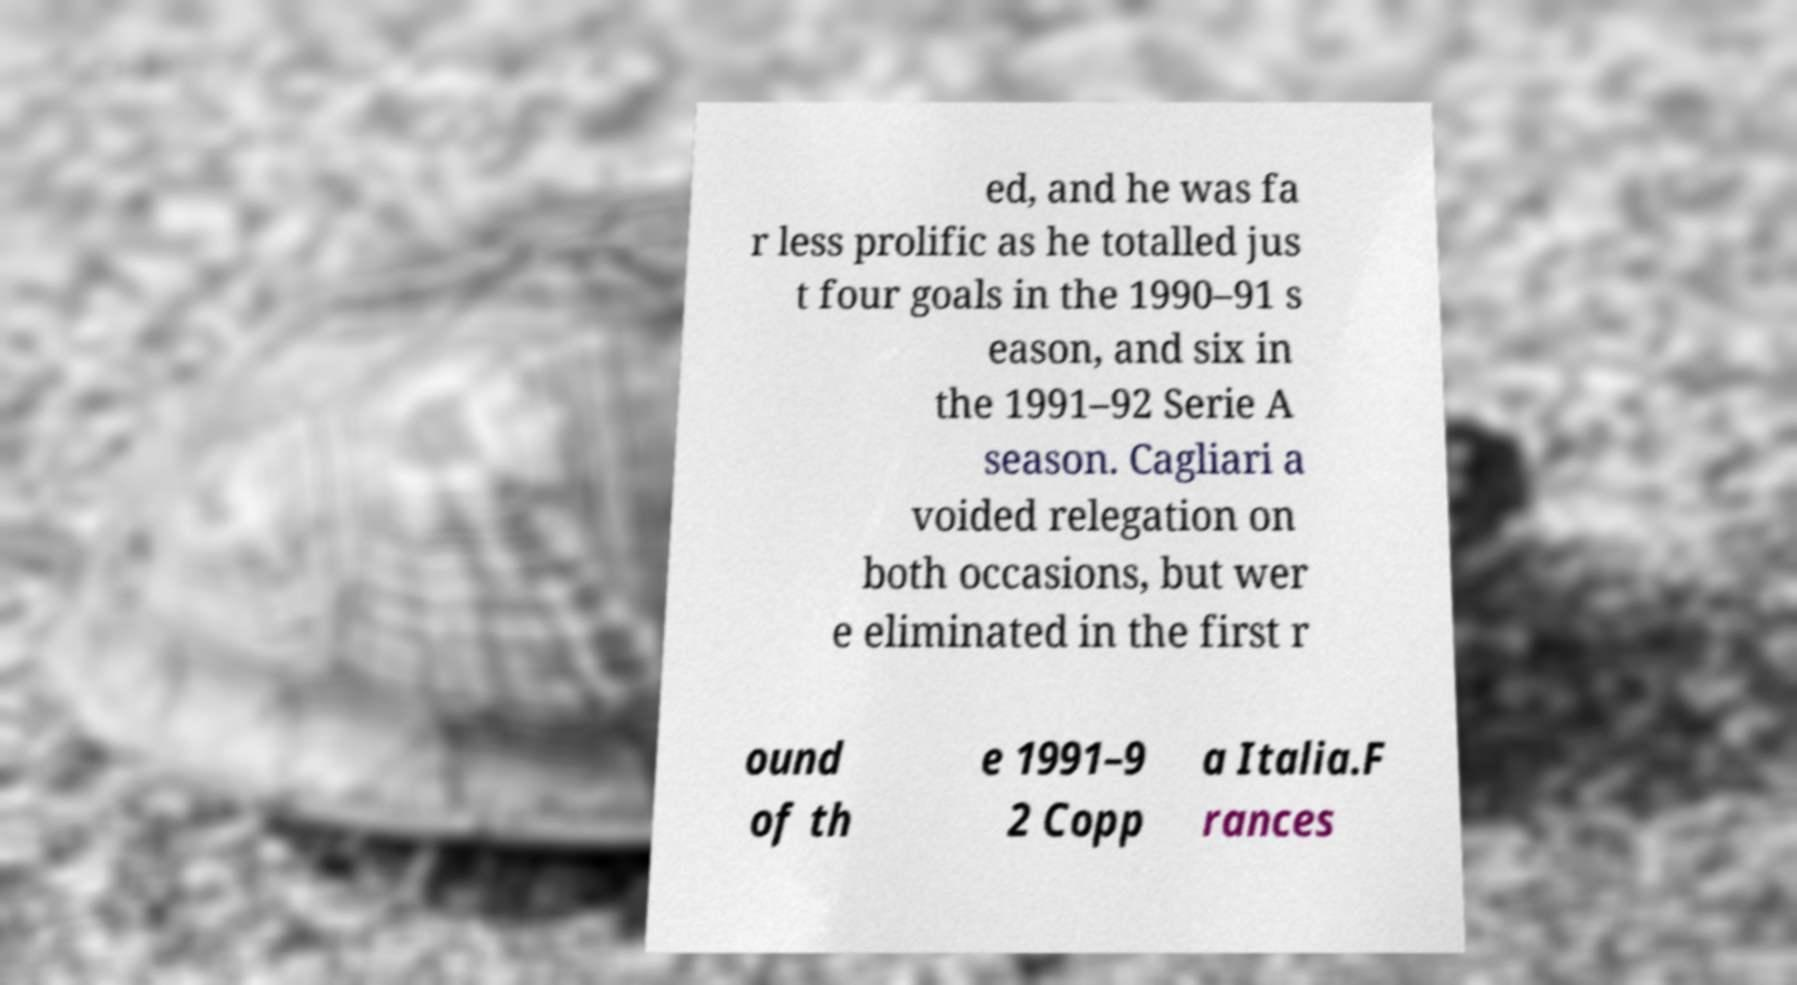Please read and relay the text visible in this image. What does it say? ed, and he was fa r less prolific as he totalled jus t four goals in the 1990–91 s eason, and six in the 1991–92 Serie A season. Cagliari a voided relegation on both occasions, but wer e eliminated in the first r ound of th e 1991–9 2 Copp a Italia.F rances 